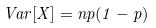<formula> <loc_0><loc_0><loc_500><loc_500>V a r [ X ] = n p ( 1 - p )</formula> 